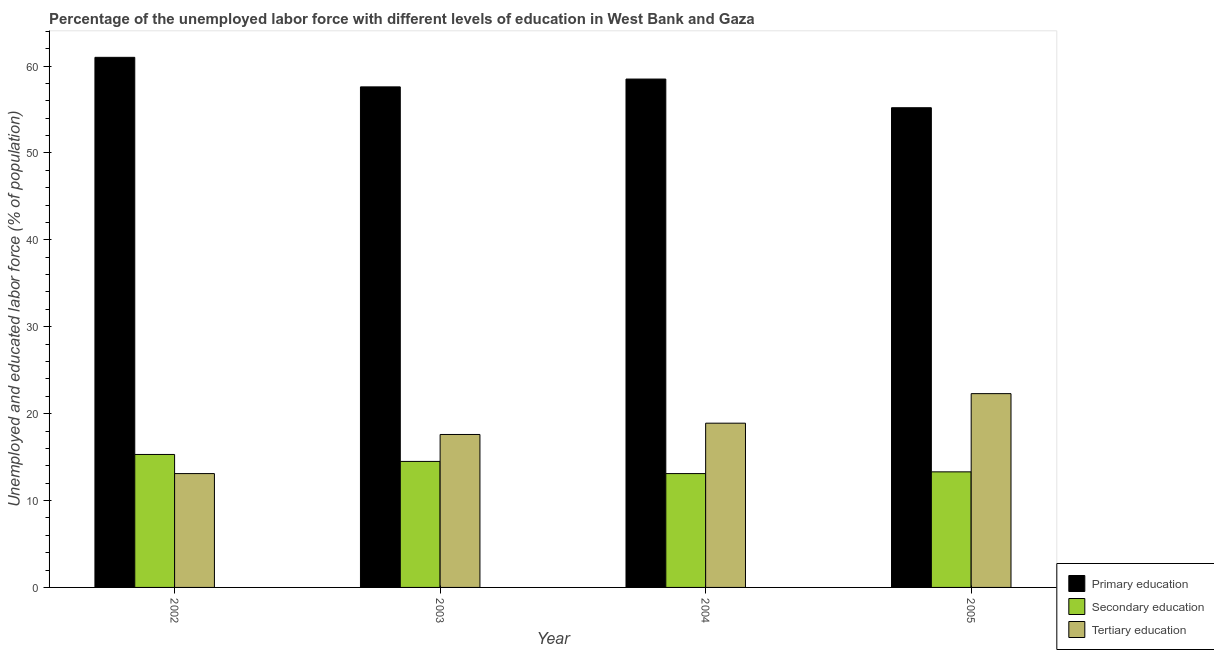How many different coloured bars are there?
Provide a succinct answer. 3. Are the number of bars per tick equal to the number of legend labels?
Ensure brevity in your answer.  Yes. How many bars are there on the 1st tick from the left?
Give a very brief answer. 3. What is the label of the 2nd group of bars from the left?
Your answer should be compact. 2003. In how many cases, is the number of bars for a given year not equal to the number of legend labels?
Offer a very short reply. 0. What is the percentage of labor force who received primary education in 2003?
Make the answer very short. 57.6. Across all years, what is the maximum percentage of labor force who received secondary education?
Make the answer very short. 15.3. Across all years, what is the minimum percentage of labor force who received primary education?
Your answer should be compact. 55.2. What is the total percentage of labor force who received tertiary education in the graph?
Your answer should be very brief. 71.9. What is the difference between the percentage of labor force who received tertiary education in 2002 and that in 2004?
Ensure brevity in your answer.  -5.8. What is the difference between the percentage of labor force who received primary education in 2003 and the percentage of labor force who received tertiary education in 2004?
Your response must be concise. -0.9. What is the average percentage of labor force who received tertiary education per year?
Your answer should be very brief. 17.97. In the year 2003, what is the difference between the percentage of labor force who received tertiary education and percentage of labor force who received secondary education?
Offer a terse response. 0. What is the ratio of the percentage of labor force who received primary education in 2002 to that in 2005?
Provide a succinct answer. 1.11. What is the difference between the highest and the second highest percentage of labor force who received tertiary education?
Give a very brief answer. 3.4. What is the difference between the highest and the lowest percentage of labor force who received secondary education?
Ensure brevity in your answer.  2.2. Is the sum of the percentage of labor force who received primary education in 2003 and 2004 greater than the maximum percentage of labor force who received tertiary education across all years?
Give a very brief answer. Yes. What does the 2nd bar from the left in 2003 represents?
Offer a terse response. Secondary education. What does the 1st bar from the right in 2002 represents?
Provide a short and direct response. Tertiary education. Is it the case that in every year, the sum of the percentage of labor force who received primary education and percentage of labor force who received secondary education is greater than the percentage of labor force who received tertiary education?
Offer a very short reply. Yes. How many bars are there?
Make the answer very short. 12. Are all the bars in the graph horizontal?
Give a very brief answer. No. How many years are there in the graph?
Provide a succinct answer. 4. Are the values on the major ticks of Y-axis written in scientific E-notation?
Make the answer very short. No. Does the graph contain grids?
Offer a very short reply. No. Where does the legend appear in the graph?
Your response must be concise. Bottom right. What is the title of the graph?
Provide a short and direct response. Percentage of the unemployed labor force with different levels of education in West Bank and Gaza. What is the label or title of the Y-axis?
Offer a very short reply. Unemployed and educated labor force (% of population). What is the Unemployed and educated labor force (% of population) of Primary education in 2002?
Provide a short and direct response. 61. What is the Unemployed and educated labor force (% of population) in Secondary education in 2002?
Give a very brief answer. 15.3. What is the Unemployed and educated labor force (% of population) in Tertiary education in 2002?
Your answer should be compact. 13.1. What is the Unemployed and educated labor force (% of population) in Primary education in 2003?
Your answer should be very brief. 57.6. What is the Unemployed and educated labor force (% of population) in Secondary education in 2003?
Ensure brevity in your answer.  14.5. What is the Unemployed and educated labor force (% of population) of Tertiary education in 2003?
Provide a short and direct response. 17.6. What is the Unemployed and educated labor force (% of population) in Primary education in 2004?
Make the answer very short. 58.5. What is the Unemployed and educated labor force (% of population) of Secondary education in 2004?
Your response must be concise. 13.1. What is the Unemployed and educated labor force (% of population) in Tertiary education in 2004?
Offer a very short reply. 18.9. What is the Unemployed and educated labor force (% of population) in Primary education in 2005?
Provide a short and direct response. 55.2. What is the Unemployed and educated labor force (% of population) in Secondary education in 2005?
Give a very brief answer. 13.3. What is the Unemployed and educated labor force (% of population) of Tertiary education in 2005?
Offer a very short reply. 22.3. Across all years, what is the maximum Unemployed and educated labor force (% of population) of Secondary education?
Your answer should be compact. 15.3. Across all years, what is the maximum Unemployed and educated labor force (% of population) of Tertiary education?
Your answer should be very brief. 22.3. Across all years, what is the minimum Unemployed and educated labor force (% of population) of Primary education?
Your answer should be very brief. 55.2. Across all years, what is the minimum Unemployed and educated labor force (% of population) in Secondary education?
Offer a terse response. 13.1. Across all years, what is the minimum Unemployed and educated labor force (% of population) in Tertiary education?
Make the answer very short. 13.1. What is the total Unemployed and educated labor force (% of population) in Primary education in the graph?
Give a very brief answer. 232.3. What is the total Unemployed and educated labor force (% of population) of Secondary education in the graph?
Your answer should be very brief. 56.2. What is the total Unemployed and educated labor force (% of population) of Tertiary education in the graph?
Ensure brevity in your answer.  71.9. What is the difference between the Unemployed and educated labor force (% of population) in Secondary education in 2002 and that in 2003?
Provide a short and direct response. 0.8. What is the difference between the Unemployed and educated labor force (% of population) in Secondary education in 2002 and that in 2004?
Your answer should be very brief. 2.2. What is the difference between the Unemployed and educated labor force (% of population) of Tertiary education in 2002 and that in 2004?
Offer a terse response. -5.8. What is the difference between the Unemployed and educated labor force (% of population) of Primary education in 2002 and that in 2005?
Your response must be concise. 5.8. What is the difference between the Unemployed and educated labor force (% of population) of Secondary education in 2002 and that in 2005?
Offer a terse response. 2. What is the difference between the Unemployed and educated labor force (% of population) in Secondary education in 2003 and that in 2004?
Provide a succinct answer. 1.4. What is the difference between the Unemployed and educated labor force (% of population) in Primary education in 2003 and that in 2005?
Your answer should be compact. 2.4. What is the difference between the Unemployed and educated labor force (% of population) of Secondary education in 2003 and that in 2005?
Offer a very short reply. 1.2. What is the difference between the Unemployed and educated labor force (% of population) in Tertiary education in 2003 and that in 2005?
Offer a terse response. -4.7. What is the difference between the Unemployed and educated labor force (% of population) of Primary education in 2004 and that in 2005?
Ensure brevity in your answer.  3.3. What is the difference between the Unemployed and educated labor force (% of population) of Primary education in 2002 and the Unemployed and educated labor force (% of population) of Secondary education in 2003?
Make the answer very short. 46.5. What is the difference between the Unemployed and educated labor force (% of population) of Primary education in 2002 and the Unemployed and educated labor force (% of population) of Tertiary education in 2003?
Provide a short and direct response. 43.4. What is the difference between the Unemployed and educated labor force (% of population) of Primary education in 2002 and the Unemployed and educated labor force (% of population) of Secondary education in 2004?
Your response must be concise. 47.9. What is the difference between the Unemployed and educated labor force (% of population) in Primary education in 2002 and the Unemployed and educated labor force (% of population) in Tertiary education in 2004?
Offer a terse response. 42.1. What is the difference between the Unemployed and educated labor force (% of population) of Secondary education in 2002 and the Unemployed and educated labor force (% of population) of Tertiary education in 2004?
Give a very brief answer. -3.6. What is the difference between the Unemployed and educated labor force (% of population) of Primary education in 2002 and the Unemployed and educated labor force (% of population) of Secondary education in 2005?
Provide a short and direct response. 47.7. What is the difference between the Unemployed and educated labor force (% of population) of Primary education in 2002 and the Unemployed and educated labor force (% of population) of Tertiary education in 2005?
Your answer should be compact. 38.7. What is the difference between the Unemployed and educated labor force (% of population) in Primary education in 2003 and the Unemployed and educated labor force (% of population) in Secondary education in 2004?
Make the answer very short. 44.5. What is the difference between the Unemployed and educated labor force (% of population) of Primary education in 2003 and the Unemployed and educated labor force (% of population) of Tertiary education in 2004?
Your answer should be compact. 38.7. What is the difference between the Unemployed and educated labor force (% of population) in Primary education in 2003 and the Unemployed and educated labor force (% of population) in Secondary education in 2005?
Your answer should be very brief. 44.3. What is the difference between the Unemployed and educated labor force (% of population) of Primary education in 2003 and the Unemployed and educated labor force (% of population) of Tertiary education in 2005?
Keep it short and to the point. 35.3. What is the difference between the Unemployed and educated labor force (% of population) of Secondary education in 2003 and the Unemployed and educated labor force (% of population) of Tertiary education in 2005?
Provide a succinct answer. -7.8. What is the difference between the Unemployed and educated labor force (% of population) in Primary education in 2004 and the Unemployed and educated labor force (% of population) in Secondary education in 2005?
Make the answer very short. 45.2. What is the difference between the Unemployed and educated labor force (% of population) in Primary education in 2004 and the Unemployed and educated labor force (% of population) in Tertiary education in 2005?
Provide a succinct answer. 36.2. What is the difference between the Unemployed and educated labor force (% of population) in Secondary education in 2004 and the Unemployed and educated labor force (% of population) in Tertiary education in 2005?
Your response must be concise. -9.2. What is the average Unemployed and educated labor force (% of population) of Primary education per year?
Ensure brevity in your answer.  58.08. What is the average Unemployed and educated labor force (% of population) in Secondary education per year?
Your response must be concise. 14.05. What is the average Unemployed and educated labor force (% of population) in Tertiary education per year?
Provide a short and direct response. 17.98. In the year 2002, what is the difference between the Unemployed and educated labor force (% of population) of Primary education and Unemployed and educated labor force (% of population) of Secondary education?
Provide a short and direct response. 45.7. In the year 2002, what is the difference between the Unemployed and educated labor force (% of population) of Primary education and Unemployed and educated labor force (% of population) of Tertiary education?
Your answer should be compact. 47.9. In the year 2002, what is the difference between the Unemployed and educated labor force (% of population) in Secondary education and Unemployed and educated labor force (% of population) in Tertiary education?
Keep it short and to the point. 2.2. In the year 2003, what is the difference between the Unemployed and educated labor force (% of population) of Primary education and Unemployed and educated labor force (% of population) of Secondary education?
Your response must be concise. 43.1. In the year 2003, what is the difference between the Unemployed and educated labor force (% of population) of Primary education and Unemployed and educated labor force (% of population) of Tertiary education?
Make the answer very short. 40. In the year 2004, what is the difference between the Unemployed and educated labor force (% of population) in Primary education and Unemployed and educated labor force (% of population) in Secondary education?
Your answer should be very brief. 45.4. In the year 2004, what is the difference between the Unemployed and educated labor force (% of population) in Primary education and Unemployed and educated labor force (% of population) in Tertiary education?
Provide a short and direct response. 39.6. In the year 2004, what is the difference between the Unemployed and educated labor force (% of population) in Secondary education and Unemployed and educated labor force (% of population) in Tertiary education?
Your answer should be very brief. -5.8. In the year 2005, what is the difference between the Unemployed and educated labor force (% of population) in Primary education and Unemployed and educated labor force (% of population) in Secondary education?
Give a very brief answer. 41.9. In the year 2005, what is the difference between the Unemployed and educated labor force (% of population) of Primary education and Unemployed and educated labor force (% of population) of Tertiary education?
Ensure brevity in your answer.  32.9. What is the ratio of the Unemployed and educated labor force (% of population) in Primary education in 2002 to that in 2003?
Offer a very short reply. 1.06. What is the ratio of the Unemployed and educated labor force (% of population) of Secondary education in 2002 to that in 2003?
Your answer should be compact. 1.06. What is the ratio of the Unemployed and educated labor force (% of population) of Tertiary education in 2002 to that in 2003?
Make the answer very short. 0.74. What is the ratio of the Unemployed and educated labor force (% of population) in Primary education in 2002 to that in 2004?
Keep it short and to the point. 1.04. What is the ratio of the Unemployed and educated labor force (% of population) in Secondary education in 2002 to that in 2004?
Provide a short and direct response. 1.17. What is the ratio of the Unemployed and educated labor force (% of population) of Tertiary education in 2002 to that in 2004?
Your response must be concise. 0.69. What is the ratio of the Unemployed and educated labor force (% of population) of Primary education in 2002 to that in 2005?
Your answer should be very brief. 1.11. What is the ratio of the Unemployed and educated labor force (% of population) of Secondary education in 2002 to that in 2005?
Offer a terse response. 1.15. What is the ratio of the Unemployed and educated labor force (% of population) of Tertiary education in 2002 to that in 2005?
Your answer should be compact. 0.59. What is the ratio of the Unemployed and educated labor force (% of population) of Primary education in 2003 to that in 2004?
Offer a very short reply. 0.98. What is the ratio of the Unemployed and educated labor force (% of population) of Secondary education in 2003 to that in 2004?
Provide a succinct answer. 1.11. What is the ratio of the Unemployed and educated labor force (% of population) in Tertiary education in 2003 to that in 2004?
Your answer should be very brief. 0.93. What is the ratio of the Unemployed and educated labor force (% of population) of Primary education in 2003 to that in 2005?
Make the answer very short. 1.04. What is the ratio of the Unemployed and educated labor force (% of population) of Secondary education in 2003 to that in 2005?
Ensure brevity in your answer.  1.09. What is the ratio of the Unemployed and educated labor force (% of population) in Tertiary education in 2003 to that in 2005?
Make the answer very short. 0.79. What is the ratio of the Unemployed and educated labor force (% of population) of Primary education in 2004 to that in 2005?
Offer a terse response. 1.06. What is the ratio of the Unemployed and educated labor force (% of population) in Tertiary education in 2004 to that in 2005?
Your response must be concise. 0.85. What is the difference between the highest and the second highest Unemployed and educated labor force (% of population) in Primary education?
Ensure brevity in your answer.  2.5. What is the difference between the highest and the second highest Unemployed and educated labor force (% of population) in Tertiary education?
Your answer should be compact. 3.4. What is the difference between the highest and the lowest Unemployed and educated labor force (% of population) of Secondary education?
Your response must be concise. 2.2. 